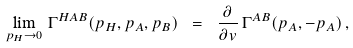Convert formula to latex. <formula><loc_0><loc_0><loc_500><loc_500>\lim _ { p _ { H } \to 0 } \, \Gamma ^ { H A B } ( p _ { H } , p _ { A } , p _ { B } ) \ = \ \frac { \partial } { \partial v } \, \Gamma ^ { A B } ( p _ { A } , - p _ { A } ) \, ,</formula> 